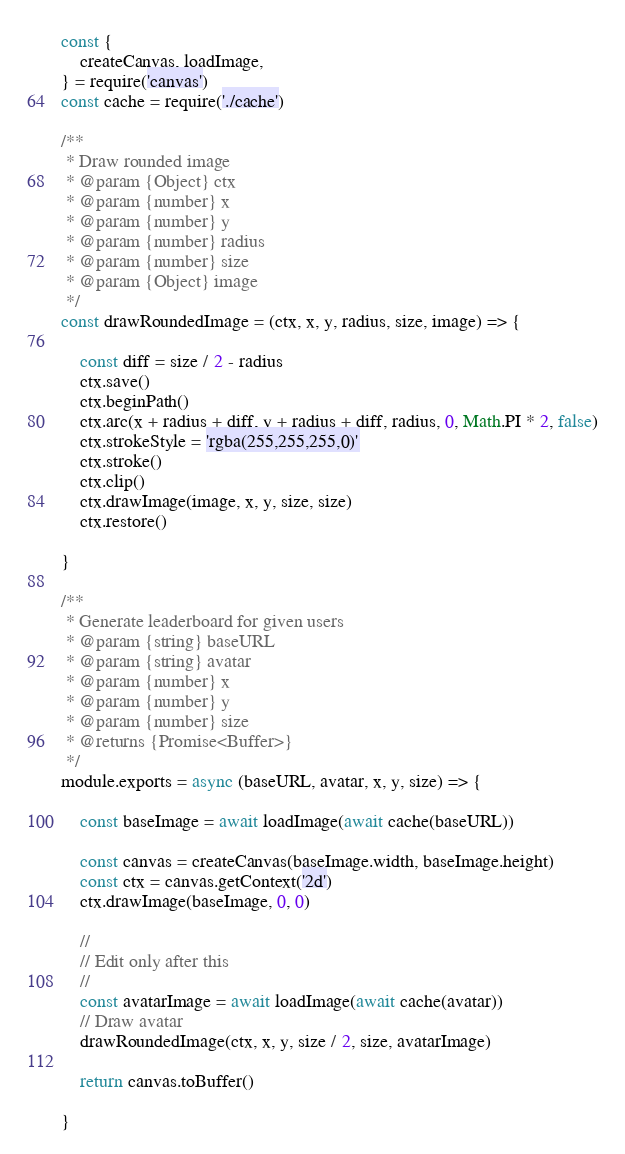<code> <loc_0><loc_0><loc_500><loc_500><_JavaScript_>const {
    createCanvas, loadImage,
} = require('canvas')
const cache = require('./cache')

/**
 * Draw rounded image
 * @param {Object} ctx
 * @param {number} x
 * @param {number} y
 * @param {number} radius
 * @param {number} size
 * @param {Object} image
 */
const drawRoundedImage = (ctx, x, y, radius, size, image) => {

    const diff = size / 2 - radius
    ctx.save()
    ctx.beginPath()
    ctx.arc(x + radius + diff, y + radius + diff, radius, 0, Math.PI * 2, false)
    ctx.strokeStyle = 'rgba(255,255,255,0)'
    ctx.stroke()
    ctx.clip()
    ctx.drawImage(image, x, y, size, size)
    ctx.restore()

}

/**
 * Generate leaderboard for given users
 * @param {string} baseURL
 * @param {string} avatar
 * @param {number} x
 * @param {number} y
 * @param {number} size
 * @returns {Promise<Buffer>}
 */
module.exports = async (baseURL, avatar, x, y, size) => {

    const baseImage = await loadImage(await cache(baseURL))

    const canvas = createCanvas(baseImage.width, baseImage.height)
    const ctx = canvas.getContext('2d')
    ctx.drawImage(baseImage, 0, 0)

    //
    // Edit only after this
    //
    const avatarImage = await loadImage(await cache(avatar))
    // Draw avatar
    drawRoundedImage(ctx, x, y, size / 2, size, avatarImage)

    return canvas.toBuffer()

}
</code> 